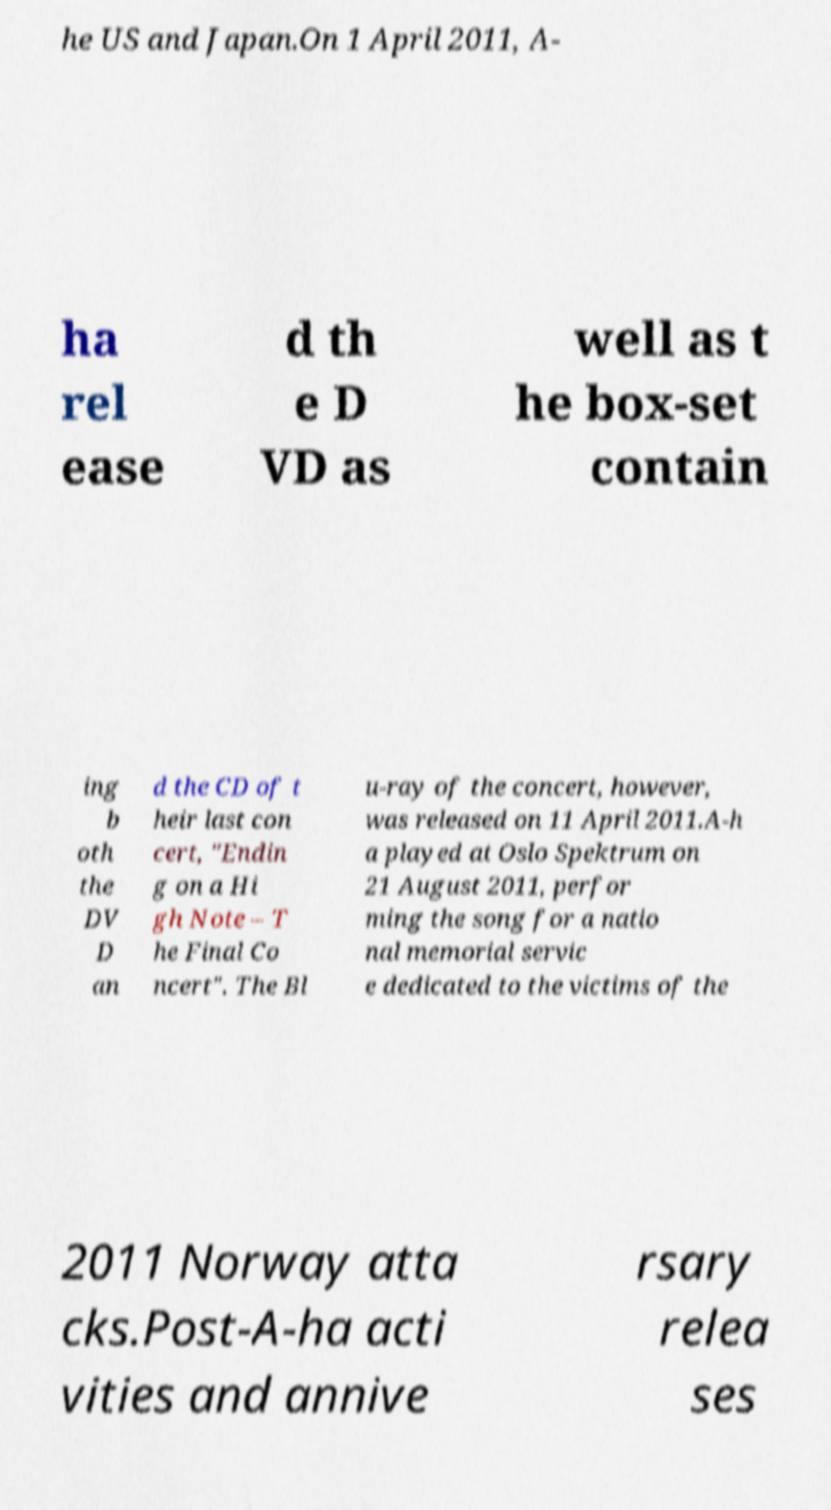Please read and relay the text visible in this image. What does it say? he US and Japan.On 1 April 2011, A- ha rel ease d th e D VD as well as t he box-set contain ing b oth the DV D an d the CD of t heir last con cert, "Endin g on a Hi gh Note – T he Final Co ncert". The Bl u-ray of the concert, however, was released on 11 April 2011.A-h a played at Oslo Spektrum on 21 August 2011, perfor ming the song for a natio nal memorial servic e dedicated to the victims of the 2011 Norway atta cks.Post-A-ha acti vities and annive rsary relea ses 